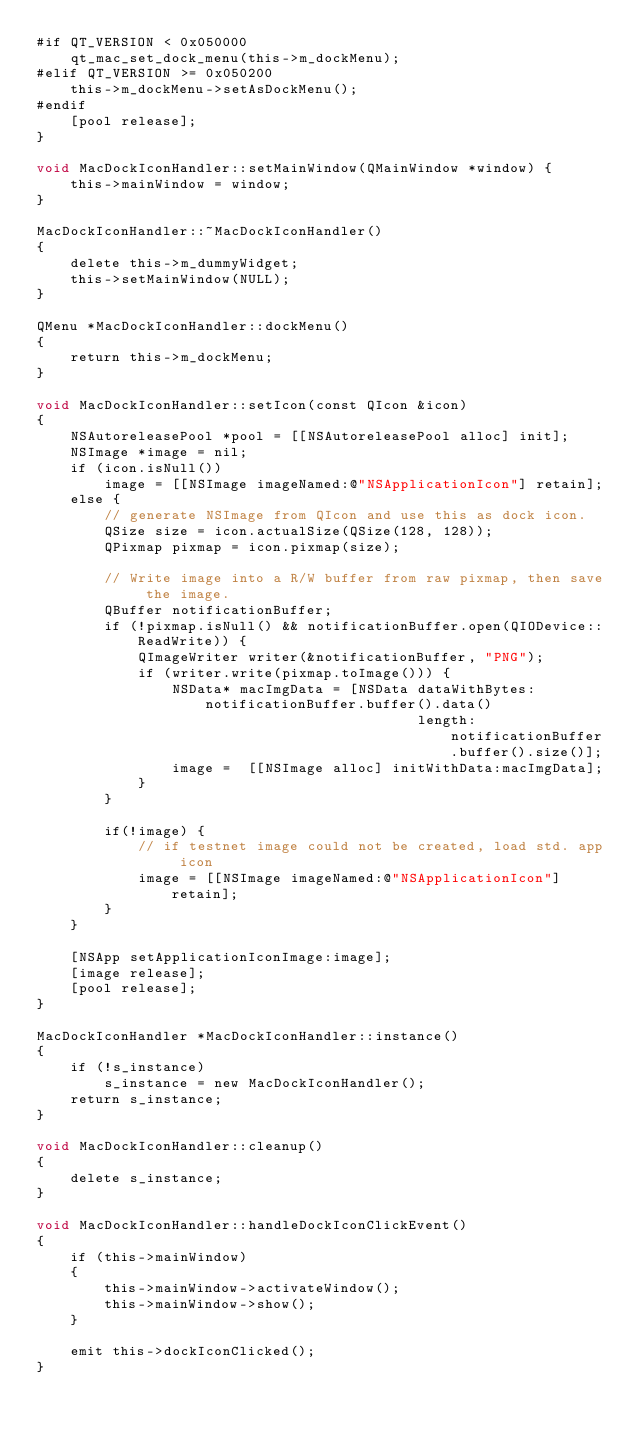Convert code to text. <code><loc_0><loc_0><loc_500><loc_500><_ObjectiveC_>#if QT_VERSION < 0x050000
    qt_mac_set_dock_menu(this->m_dockMenu);
#elif QT_VERSION >= 0x050200
    this->m_dockMenu->setAsDockMenu();
#endif
    [pool release];
}

void MacDockIconHandler::setMainWindow(QMainWindow *window) {
    this->mainWindow = window;
}

MacDockIconHandler::~MacDockIconHandler()
{
    delete this->m_dummyWidget;
    this->setMainWindow(NULL);
}

QMenu *MacDockIconHandler::dockMenu()
{
    return this->m_dockMenu;
}

void MacDockIconHandler::setIcon(const QIcon &icon)
{
    NSAutoreleasePool *pool = [[NSAutoreleasePool alloc] init];
    NSImage *image = nil;
    if (icon.isNull())
        image = [[NSImage imageNamed:@"NSApplicationIcon"] retain];
    else {
        // generate NSImage from QIcon and use this as dock icon.
        QSize size = icon.actualSize(QSize(128, 128));
        QPixmap pixmap = icon.pixmap(size);

        // Write image into a R/W buffer from raw pixmap, then save the image.
        QBuffer notificationBuffer;
        if (!pixmap.isNull() && notificationBuffer.open(QIODevice::ReadWrite)) {
            QImageWriter writer(&notificationBuffer, "PNG");
            if (writer.write(pixmap.toImage())) {
                NSData* macImgData = [NSData dataWithBytes:notificationBuffer.buffer().data()
                                             length:notificationBuffer.buffer().size()];
                image =  [[NSImage alloc] initWithData:macImgData];
            }
        }

        if(!image) {
            // if testnet image could not be created, load std. app icon
            image = [[NSImage imageNamed:@"NSApplicationIcon"] retain];
        }
    }

    [NSApp setApplicationIconImage:image];
    [image release];
    [pool release];
}

MacDockIconHandler *MacDockIconHandler::instance()
{
    if (!s_instance)
        s_instance = new MacDockIconHandler();
    return s_instance;
}

void MacDockIconHandler::cleanup()
{
    delete s_instance;
}

void MacDockIconHandler::handleDockIconClickEvent()
{
    if (this->mainWindow)
    {
        this->mainWindow->activateWindow();
        this->mainWindow->show();
    }

    emit this->dockIconClicked();
}
</code> 